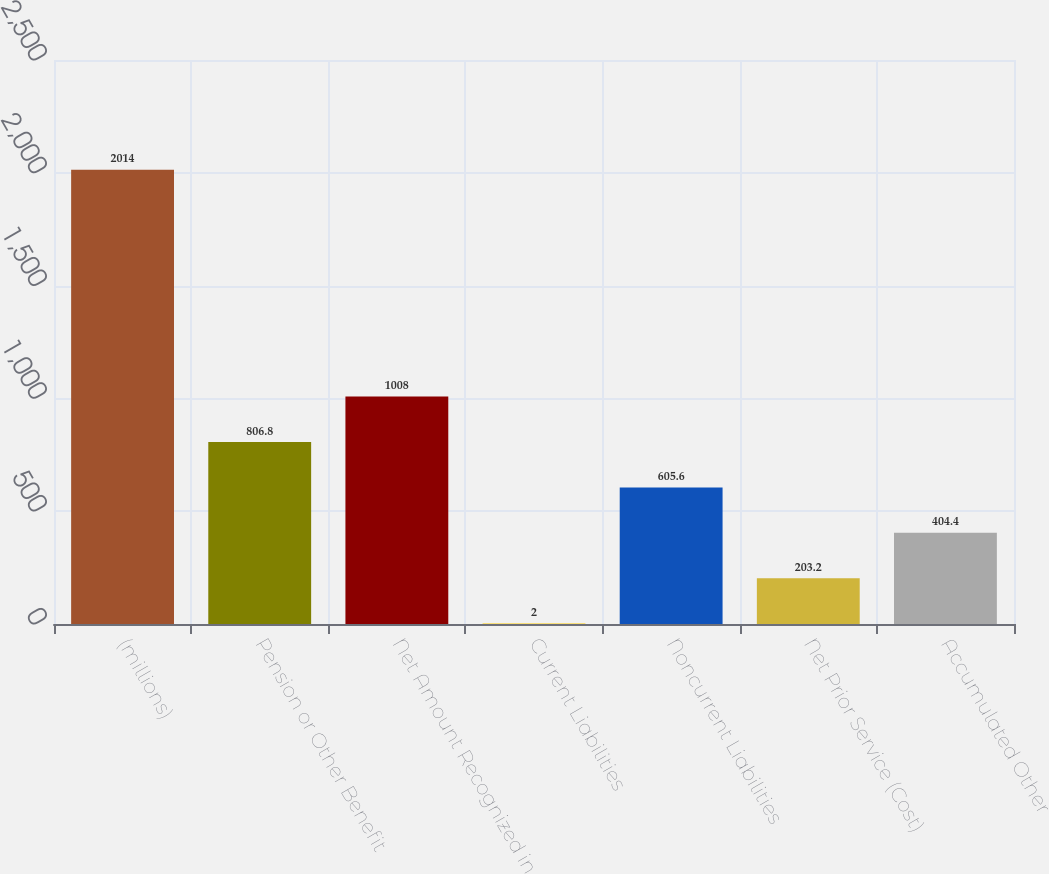<chart> <loc_0><loc_0><loc_500><loc_500><bar_chart><fcel>(millions)<fcel>Pension or Other Benefit<fcel>Net Amount Recognized in<fcel>Current Liabilities<fcel>Noncurrent Liabilities<fcel>Net Prior Service (Cost)<fcel>Accumulated Other<nl><fcel>2014<fcel>806.8<fcel>1008<fcel>2<fcel>605.6<fcel>203.2<fcel>404.4<nl></chart> 